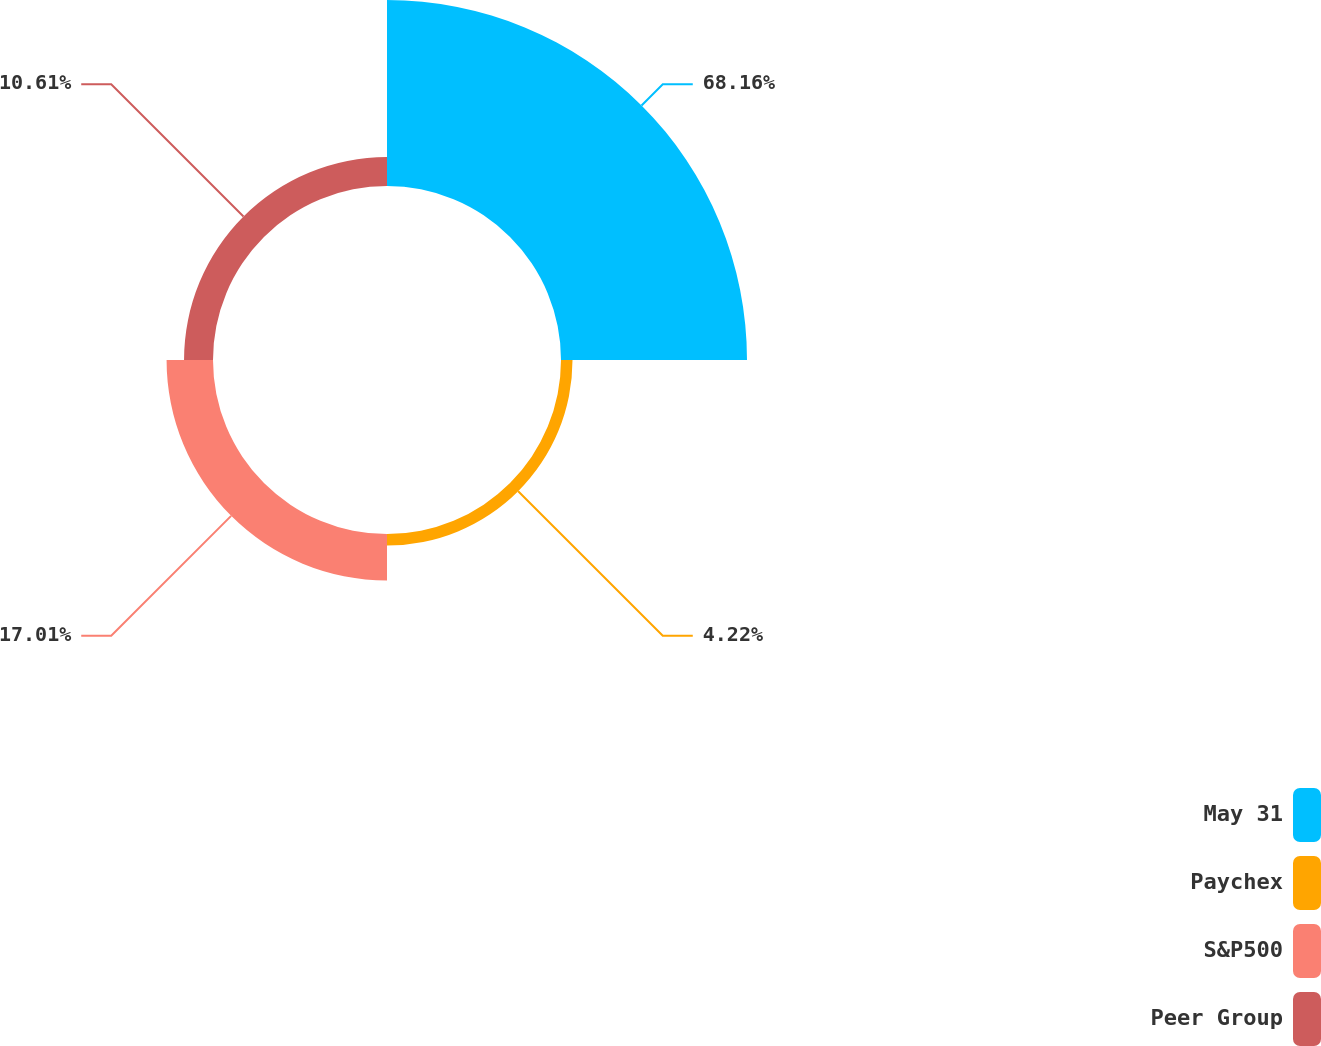<chart> <loc_0><loc_0><loc_500><loc_500><pie_chart><fcel>May 31<fcel>Paychex<fcel>S&P500<fcel>Peer Group<nl><fcel>68.16%<fcel>4.22%<fcel>17.01%<fcel>10.61%<nl></chart> 